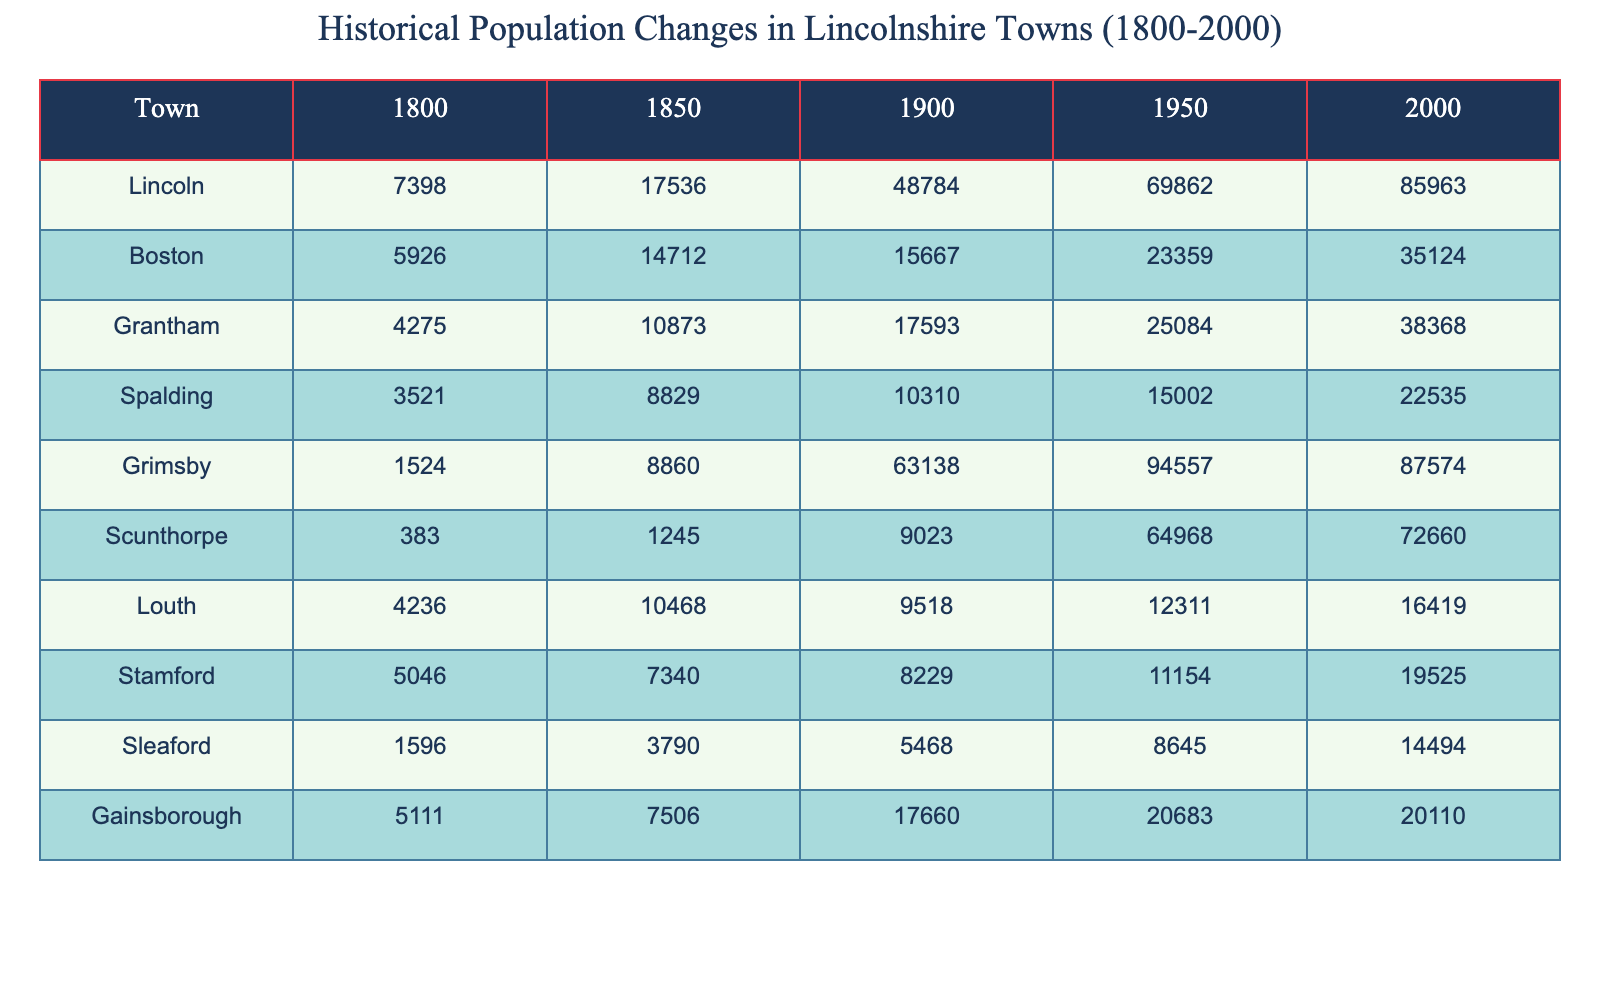What was the population of Lincoln in 1800? According to the table, the population of Lincoln in 1800 is directly listed as 7,398.
Answer: 7,398 What was the population growth of Boston from 1850 to 2000? The population of Boston in 1850 was 14,712 and in 2000 it was 35,124. The growth is calculated by subtracting the earlier figure from the later one: 35,124 - 14,712 = 20,412.
Answer: 20,412 Which town had the highest population in 1950? The highest population recorded in 1950 is for Grimsby, which had a population of 94,557, as seen in the table.
Answer: Grimsby What was the average population of Grantham over the years listed? To find the average, sum the populations for Grantham over the years: (4,275 + 10,873 + 17,593 + 25,084 + 38,368) = 96,193. There are 5 years, so the average is 96,193 / 5 = 19,238.6.
Answer: 19,238.6 Did any town decrease in population from 1900 to 2000? By checking the population figures in the table, it's clear that Gainsborough had a decrease: it had 17,660 in 1900 and 20,110 in 2000, indicating it did not decrease. Therefore, no town experienced a decrease in population in this period.
Answer: No What is the difference in population between Louth in 1950 and Spalding in 2000? Louth's population in 1950 was 12,311, and Spalding's in 2000 was 22,535. To find the difference, subtract Louth's population from Spalding's: 22,535 - 12,311 = 10,224.
Answer: 10,224 How many towns had a population of over 30,000 in the year 2000? By examining the 2000 column in the table, the towns Boston (35,124), Grantham (38,368), Lincoln (85,963), and Grimsby (87,574) exceed a population of 30,000. This makes a total of four towns.
Answer: 4 Which town had the lowest population in 1800 and what was that population? Looking at the 1800 column, it shows that Scunthorpe had the lowest population of 383, as displayed in the table.
Answer: Scunthorpe, 383 What was the overall population trend in Lincoln from 1800 to 2000? The data shows a continuous increase in population for Lincoln: it grew from 7,398 in 1800 to 85,963 in 2000. This indicates a consistent upward trend over the two centuries.
Answer: Consistent upward trend Which town experienced the most significant population increase between 1900 and 1950? From the table, Grimsby grew from 63,138 in 1900 to 94,557 in 1950, which is an increase of 31,419. Checking the other towns, it's confirmed that no other town had an increase exceeding this amount.
Answer: Grimsby, 31,419 